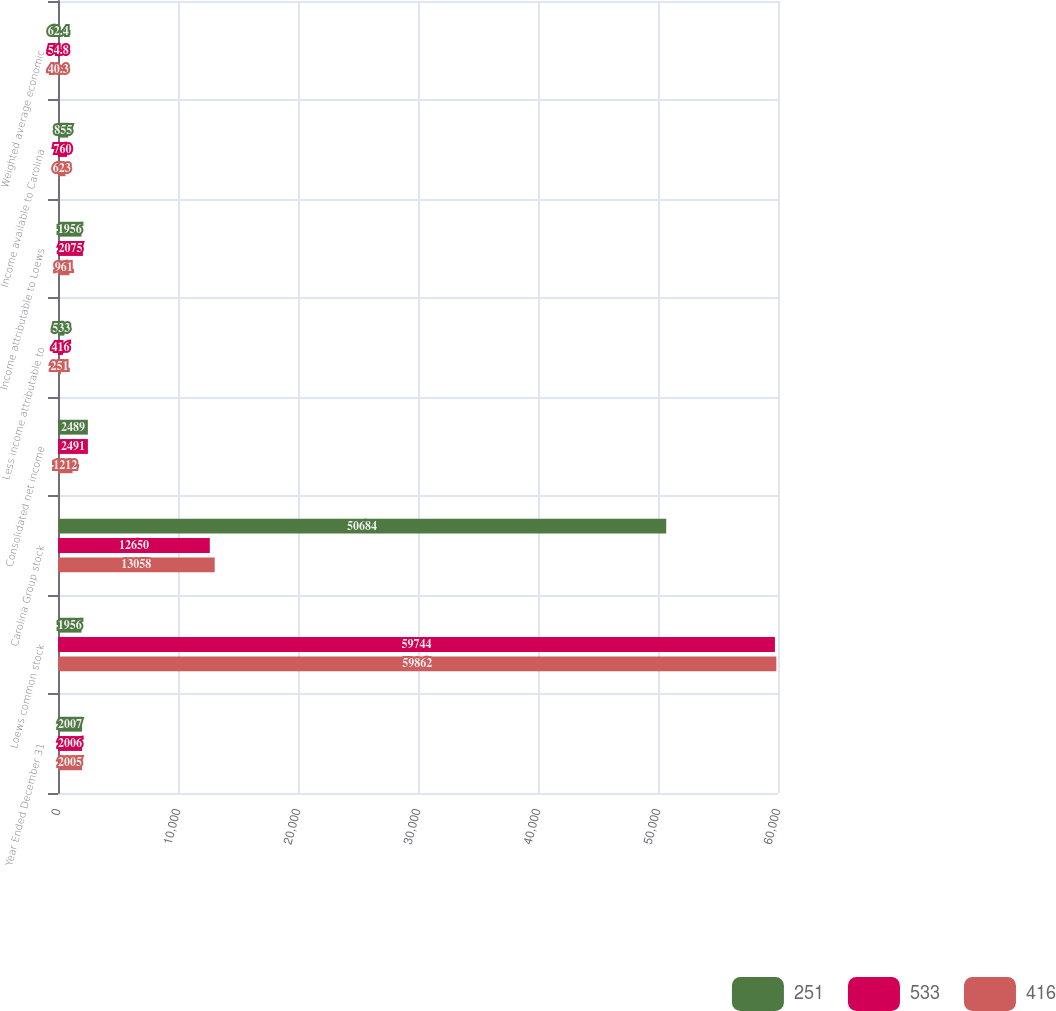Convert chart to OTSL. <chart><loc_0><loc_0><loc_500><loc_500><stacked_bar_chart><ecel><fcel>Year Ended December 31<fcel>Loews common stock<fcel>Carolina Group stock<fcel>Consolidated net income<fcel>Less income attributable to<fcel>Income attributable to Loews<fcel>Income available to Carolina<fcel>Weighted average economic<nl><fcel>251<fcel>2007<fcel>1956<fcel>50684<fcel>2489<fcel>533<fcel>1956<fcel>855<fcel>62.4<nl><fcel>533<fcel>2006<fcel>59744<fcel>12650<fcel>2491<fcel>416<fcel>2075<fcel>760<fcel>54.8<nl><fcel>416<fcel>2005<fcel>59862<fcel>13058<fcel>1212<fcel>251<fcel>961<fcel>623<fcel>40.3<nl></chart> 